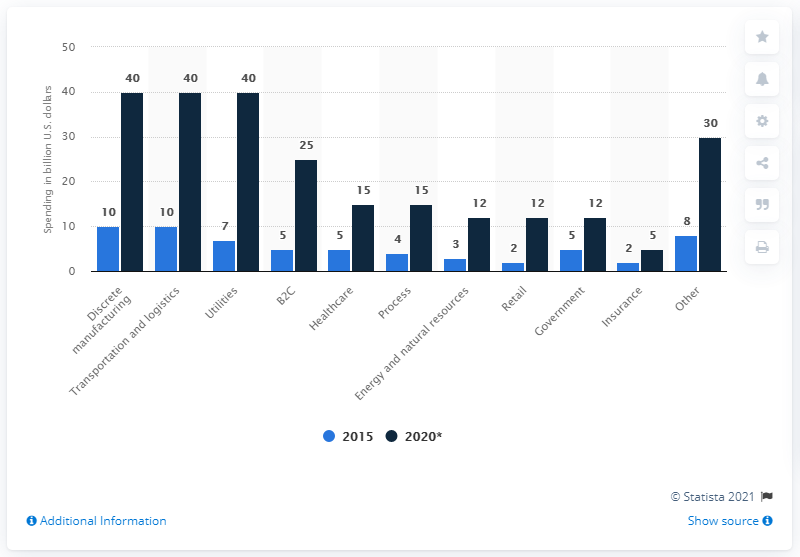Point out several critical features in this image. In 2015, the amount of IoT spending in discrete manufacturing was $10 million or more. The highest amount spent on the Internet of Things in 2020 was $40 billion. In 2015, the Healthcare sector spent the most on the Internet of Things, followed closely by the Process industry. 